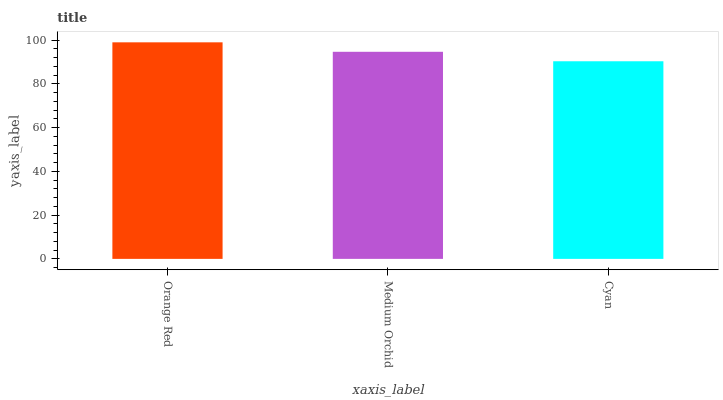Is Cyan the minimum?
Answer yes or no. Yes. Is Orange Red the maximum?
Answer yes or no. Yes. Is Medium Orchid the minimum?
Answer yes or no. No. Is Medium Orchid the maximum?
Answer yes or no. No. Is Orange Red greater than Medium Orchid?
Answer yes or no. Yes. Is Medium Orchid less than Orange Red?
Answer yes or no. Yes. Is Medium Orchid greater than Orange Red?
Answer yes or no. No. Is Orange Red less than Medium Orchid?
Answer yes or no. No. Is Medium Orchid the high median?
Answer yes or no. Yes. Is Medium Orchid the low median?
Answer yes or no. Yes. Is Cyan the high median?
Answer yes or no. No. Is Cyan the low median?
Answer yes or no. No. 